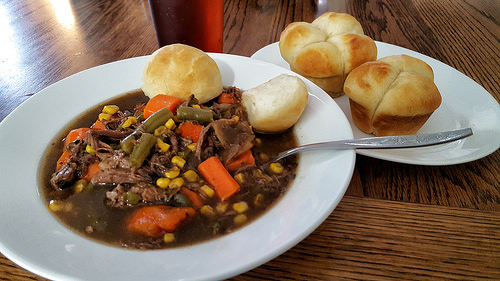<image>
Is the fork on the table? No. The fork is not positioned on the table. They may be near each other, but the fork is not supported by or resting on top of the table. 